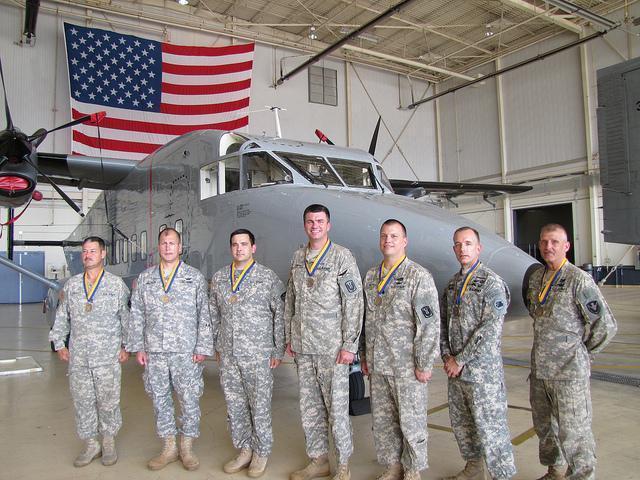How many people can you see?
Give a very brief answer. 7. 